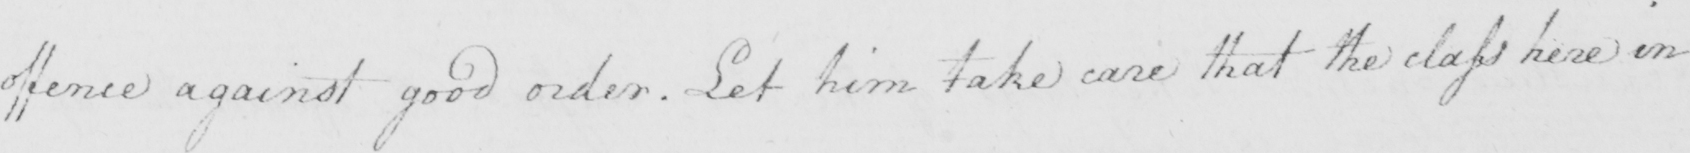Please transcribe the handwritten text in this image. offence against good order . Let him take care that the class here in 